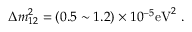Convert formula to latex. <formula><loc_0><loc_0><loc_500><loc_500>\Delta m _ { 1 2 } ^ { 2 } = ( 0 . 5 \sim 1 . 2 ) \times 1 0 ^ { - 5 } e V ^ { 2 } \ .</formula> 